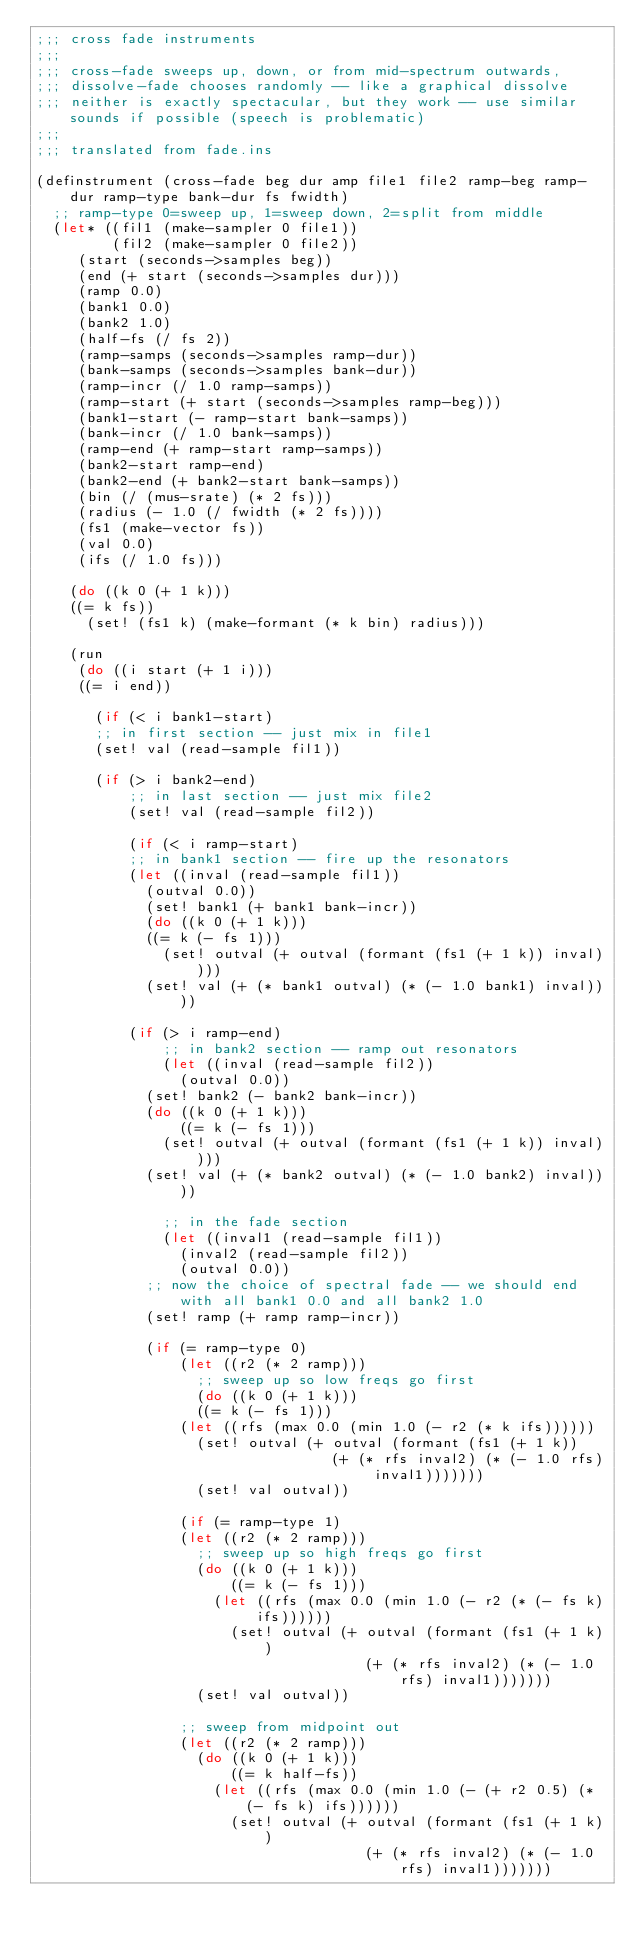Convert code to text. <code><loc_0><loc_0><loc_500><loc_500><_Scheme_>;;; cross fade instruments
;;;
;;; cross-fade sweeps up, down, or from mid-spectrum outwards,
;;; dissolve-fade chooses randomly -- like a graphical dissolve
;;; neither is exactly spectacular, but they work -- use similar sounds if possible (speech is problematic)
;;;
;;; translated from fade.ins

(definstrument (cross-fade beg dur amp file1 file2 ramp-beg ramp-dur ramp-type bank-dur fs fwidth)
  ;; ramp-type 0=sweep up, 1=sweep down, 2=split from middle
  (let* ((fil1 (make-sampler 0 file1))
         (fil2 (make-sampler 0 file2))
	 (start (seconds->samples beg))
	 (end (+ start (seconds->samples dur)))
	 (ramp 0.0)
	 (bank1 0.0)
	 (bank2 1.0)
	 (half-fs (/ fs 2))
	 (ramp-samps (seconds->samples ramp-dur))
	 (bank-samps (seconds->samples bank-dur))
	 (ramp-incr (/ 1.0 ramp-samps))
	 (ramp-start (+ start (seconds->samples ramp-beg)))
	 (bank1-start (- ramp-start bank-samps))
	 (bank-incr (/ 1.0 bank-samps))
	 (ramp-end (+ ramp-start ramp-samps))
	 (bank2-start ramp-end)
	 (bank2-end (+ bank2-start bank-samps))
	 (bin (/ (mus-srate) (* 2 fs)))
	 (radius (- 1.0 (/ fwidth (* 2 fs))))
	 (fs1 (make-vector fs))
	 (val 0.0)
	 (ifs (/ 1.0 fs)))

    (do ((k 0 (+ 1 k)))
	((= k fs))
      (set! (fs1 k) (make-formant (* k bin) radius)))

    (run
     (do ((i start (+ 1 i)))
	 ((= i end))
       
       (if (< i bank1-start)
	   ;; in first section -- just mix in file1
	   (set! val (read-sample fil1))
	   
	   (if (> i bank2-end)
	       ;; in last section -- just mix file2
	       (set! val (read-sample fil2))
	       
	       (if (< i ramp-start)
		   ;; in bank1 section -- fire up the resonators
		   (let ((inval (read-sample fil1))
			 (outval 0.0))
		     (set! bank1 (+ bank1 bank-incr))
		     (do ((k 0 (+ 1 k)))
			 ((= k (- fs 1)))
		       (set! outval (+ outval (formant (fs1 (+ 1 k)) inval))))
		     (set! val (+ (* bank1 outval) (* (- 1.0 bank1) inval))))
		   
		   (if (> i ramp-end)
		       ;; in bank2 section -- ramp out resonators
		       (let ((inval (read-sample fil2))
			     (outval 0.0))
			 (set! bank2 (- bank2 bank-incr))
			 (do ((k 0 (+ 1 k)))
			     ((= k (- fs 1)))
			   (set! outval (+ outval (formant (fs1 (+ 1 k)) inval))))
			 (set! val (+ (* bank2 outval) (* (- 1.0 bank2) inval))))
		       
		       ;; in the fade section
		       (let ((inval1 (read-sample fil1))
			     (inval2 (read-sample fil2))
			     (outval 0.0))
			 ;; now the choice of spectral fade -- we should end with all bank1 0.0 and all bank2 1.0
			 (set! ramp (+ ramp ramp-incr))
			 
			 (if (= ramp-type 0)
			     (let ((r2 (* 2 ramp)))
			       ;; sweep up so low freqs go first
			       (do ((k 0 (+ 1 k)))
				   ((= k (- fs 1)))
				 (let ((rfs (max 0.0 (min 1.0 (- r2 (* k ifs))))))
				   (set! outval (+ outval (formant (fs1 (+ 1 k)) 
								   (+ (* rfs inval2) (* (- 1.0 rfs) inval1)))))))
			       (set! val outval))
			     
			     (if (= ramp-type 1)
				 (let ((r2 (* 2 ramp)))
				   ;; sweep up so high freqs go first
				   (do ((k 0 (+ 1 k)))
				       ((= k (- fs 1)))
				     (let ((rfs (max 0.0 (min 1.0 (- r2 (* (- fs k) ifs))))))
				       (set! outval (+ outval (formant (fs1 (+ 1 k)) 
								       (+ (* rfs inval2) (* (- 1.0 rfs) inval1)))))))
				   (set! val outval))
				 
				 ;; sweep from midpoint out
				 (let ((r2 (* 2 ramp)))
				   (do ((k 0 (+ 1 k)))
				       ((= k half-fs))
				     (let ((rfs (max 0.0 (min 1.0 (- (+ r2 0.5) (* (- fs k) ifs))))))
				       (set! outval (+ outval (formant (fs1 (+ 1 k)) 
								       (+ (* rfs inval2) (* (- 1.0 rfs) inval1)))))))</code> 